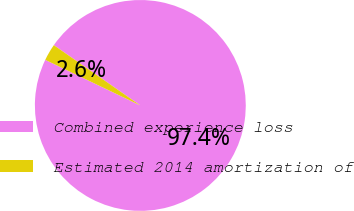Convert chart to OTSL. <chart><loc_0><loc_0><loc_500><loc_500><pie_chart><fcel>Combined experience loss<fcel>Estimated 2014 amortization of<nl><fcel>97.43%<fcel>2.57%<nl></chart> 